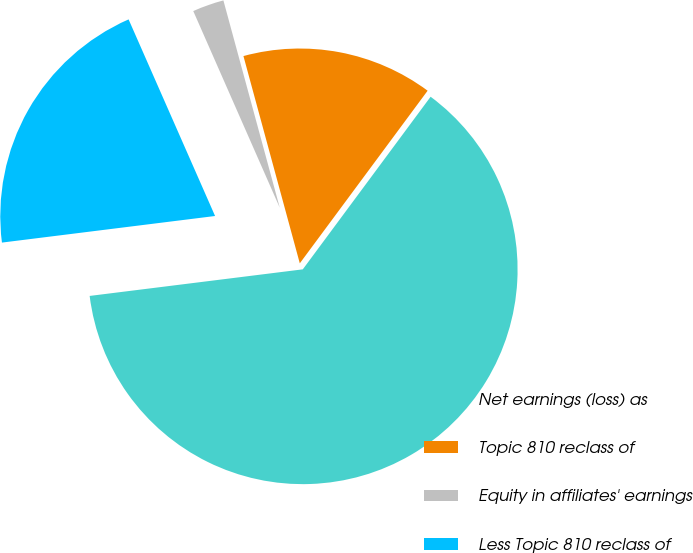Convert chart. <chart><loc_0><loc_0><loc_500><loc_500><pie_chart><fcel>Net earnings (loss) as<fcel>Topic 810 reclass of<fcel>Equity in affiliates' earnings<fcel>Less Topic 810 reclass of<nl><fcel>62.88%<fcel>14.37%<fcel>2.37%<fcel>20.38%<nl></chart> 